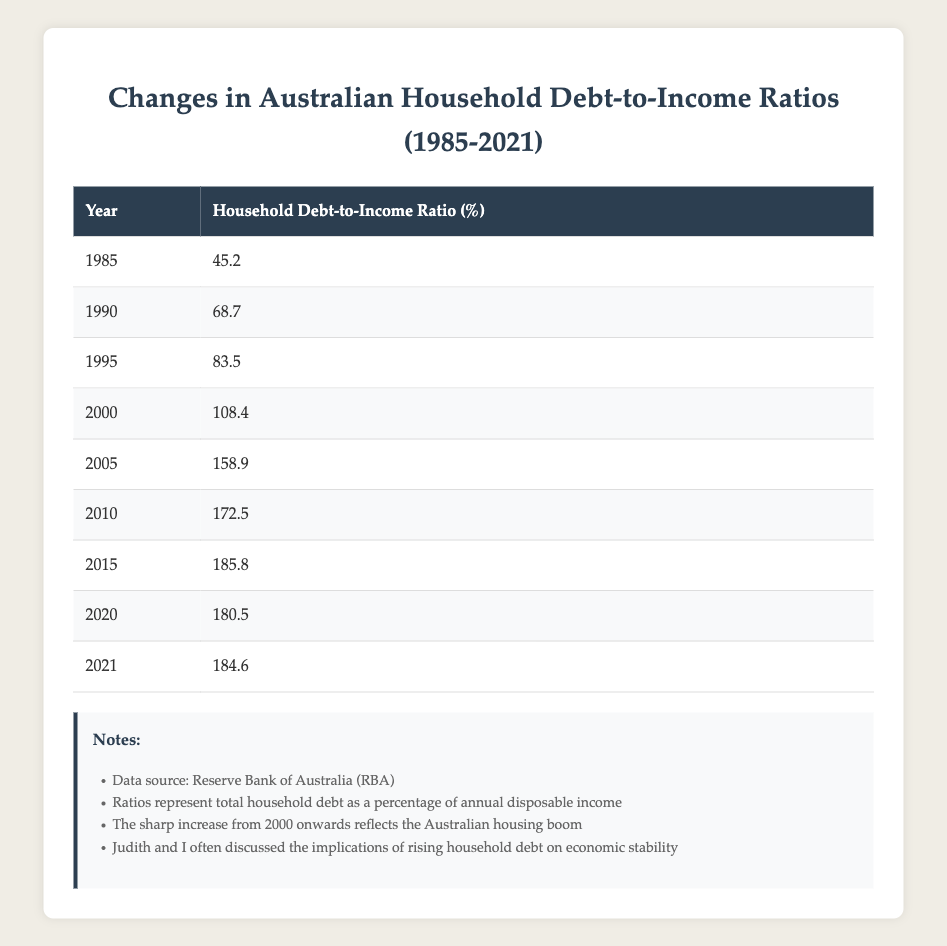What was the household debt-to-income ratio in 2000? According to the table, the entry for the year 2000 indicates a household debt-to-income ratio of 108.4%.
Answer: 108.4% Which year saw the highest household debt-to-income ratio? By examining the table, the year 2015 has the highest ratio listed at 185.8%, making it the peak year for household debt-to-income ratio in the data.
Answer: 2015 What is the increase in the household debt-to-income ratio from 1985 to 2021? The ratio for 1985 is 45.2% and for 2021 is 184.6%. To find the increase, we subtract 45.2 from 184.6, which equals 139.4%.
Answer: 139.4% Is the household debt-to-income ratio higher in 2010 than in 2005? The ratio for 2010 is 172.5% while the ratio for 2005 is 158.9%. Since 172.5% is greater than 158.9%, the statement is true.
Answer: Yes What was the average household debt-to-income ratio from 2000 to 2021? To find the average, we first sum the ratios from 2000 (108.4), 2005 (158.9), 2010 (172.5), 2015 (185.8), 2020 (180.5), and 2021 (184.6). This totals to 108.4 + 158.9 + 172.5 + 185.8 + 180.5 + 184.6 = 990.7. Dividing this sum by the number of years (6) gives us an average of 990.7 / 6 = 165.12.
Answer: 165.12 What was the household debt-to-income ratio in 2015 compared to 2020? In 2015, the ratio was 185.8%, while in 2020 it was 180.5%. Since 185.8% is greater than 180.5%, this indicates a decrease from 2015 to 2020.
Answer: Decrease How much did the household debt-to-income ratio change between 2010 and 2015? The ratio for 2010 is 172.5% and for 2015 is 185.8%. To find the change, we subtract 172.5 from 185.8, resulting in an increase of 13.3%.
Answer: 13.3% Was there a decrease in the household debt-to-income ratio from 2015 to 2020? Yes, the 2015 ratio was 185.8% while the 2020 ratio was 180.5%. Since 180.5% is less than 185.8%, it confirms that there was a decrease.
Answer: Yes 